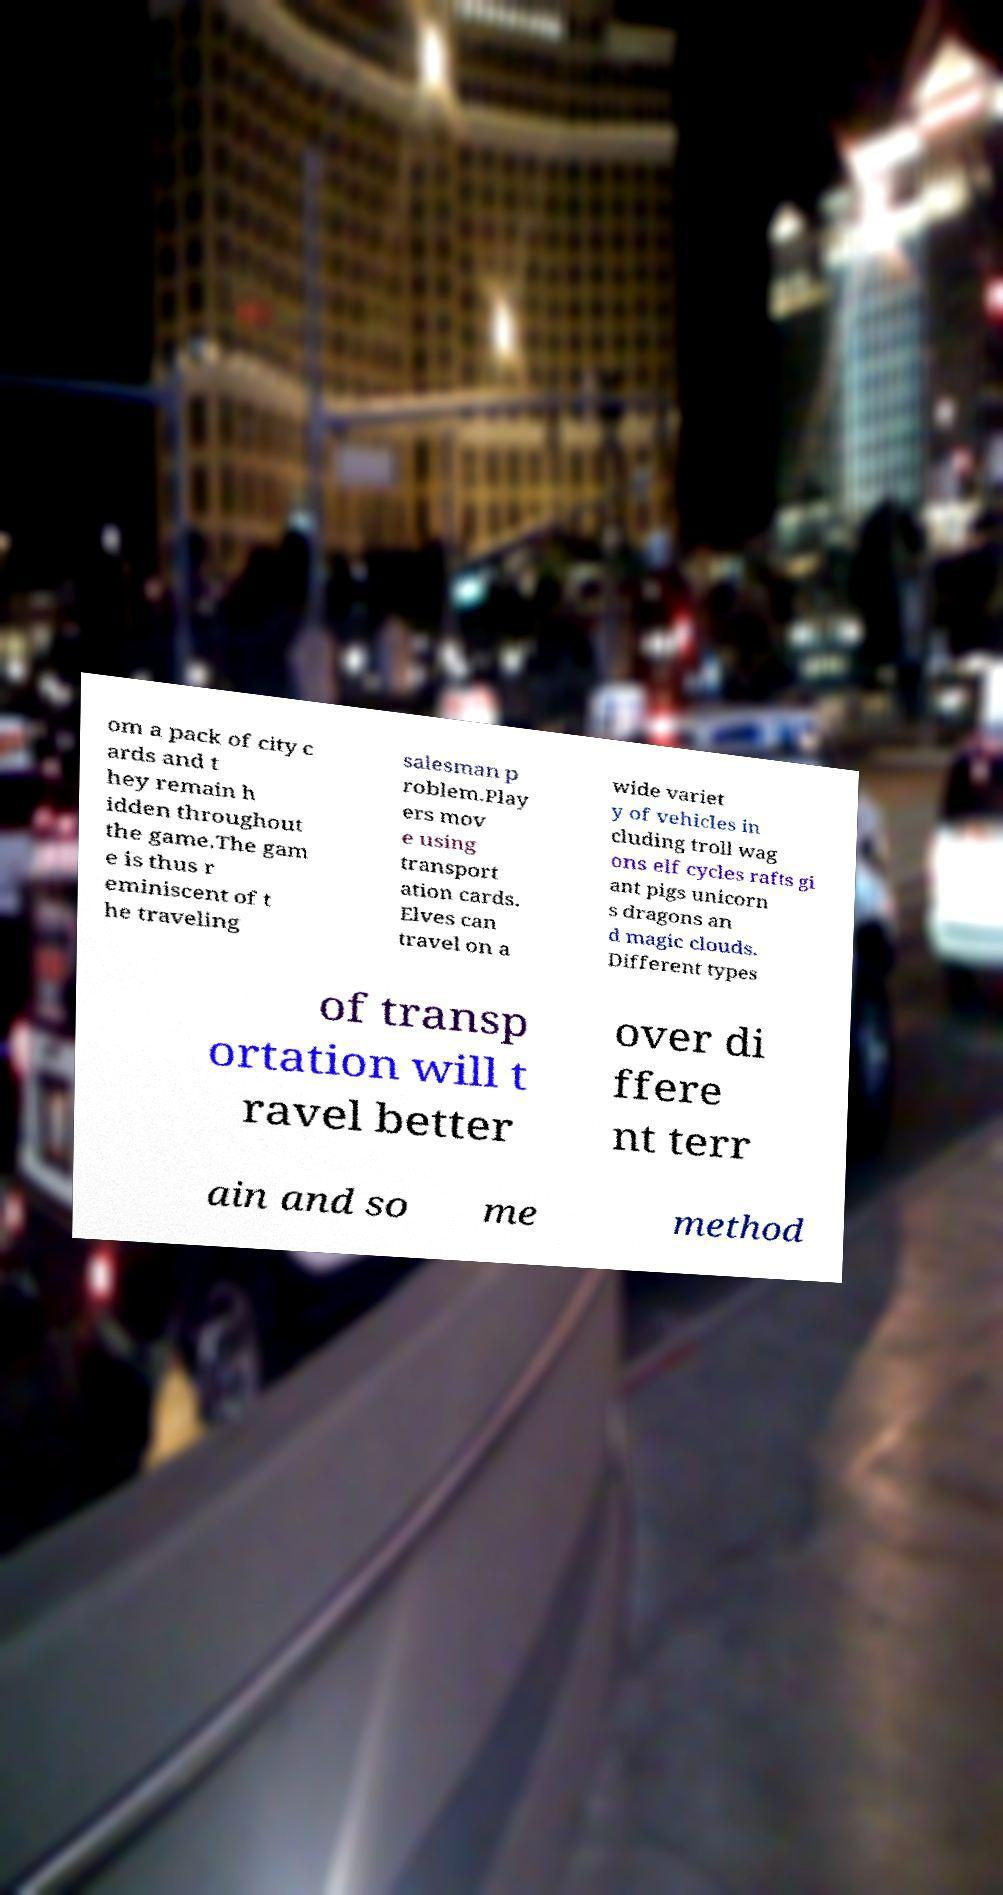Please identify and transcribe the text found in this image. om a pack of city c ards and t hey remain h idden throughout the game.The gam e is thus r eminiscent of t he traveling salesman p roblem.Play ers mov e using transport ation cards. Elves can travel on a wide variet y of vehicles in cluding troll wag ons elf cycles rafts gi ant pigs unicorn s dragons an d magic clouds. Different types of transp ortation will t ravel better over di ffere nt terr ain and so me method 